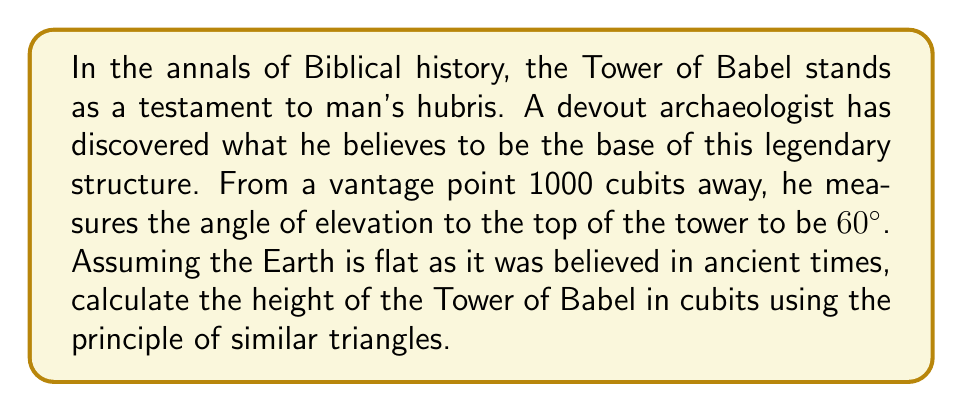Can you solve this math problem? Let us approach this problem step-by-step, using the wisdom of geometry as handed down through the ages:

1) First, let us draw a diagram to represent the situation:

[asy]
import geometry;

size(200);

pair A = (0,0), B = (10,0), C = (10,17.32);
draw(A--B--C--A);
draw(B--(10,-1), arrow=Arrow(TeXHead));
label("1000 cubits", (5,-0.5), S);
label("Tower of Babel", (10,8.66), E);
label("h", (10.5,8.66), E);
label("60°", (0.5,0.3), NW);
label("A", A, SW);
label("B", B, SE);
label("C", C, NE);
[/asy]

2) In this diagram, AB represents the distance from the archaeologist to the base of the tower (1000 cubits), BC represents the height of the tower (h), and angle BAC is 60°.

3) We can see that triangle ABC is a 30-60-90 triangle. In such a triangle, the ratio of the shorter leg (AB) to the hypotenuse (AC) is 1:2, and the ratio of the longer leg (BC) to the hypotenuse is $\frac{\sqrt{3}}{2}:1$.

4) We can express this mathematically:

   $\frac{BC}{AC} = \frac{\sqrt{3}}{2}$

5) We know that $AB = 1000$ cubits, and in a 30-60-90 triangle, $AC = 2AB$. Therefore, $AC = 2000$ cubits.

6) Substituting these values into our ratio:

   $\frac{h}{2000} = \frac{\sqrt{3}}{2}$

7) Solving for h:

   $h = 2000 \cdot \frac{\sqrt{3}}{2} = 1000\sqrt{3}$ cubits

8) To express this in decimal form:

   $h \approx 1732.05$ cubits

Thus, by the grace of geometric wisdom, we have determined the height of the Tower of Babel.
Answer: $1000\sqrt{3}$ cubits (approximately 1732.05 cubits) 